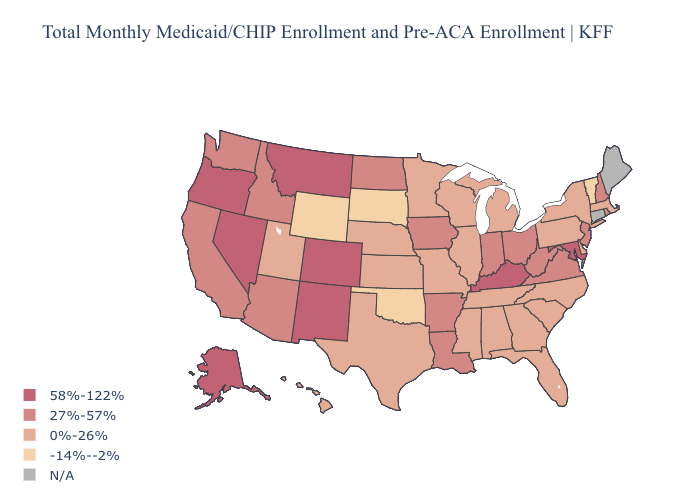Does the map have missing data?
Quick response, please. Yes. What is the value of South Dakota?
Write a very short answer. -14%--2%. Name the states that have a value in the range 58%-122%?
Short answer required. Alaska, Colorado, Kentucky, Maryland, Montana, Nevada, New Mexico, Oregon. What is the lowest value in the West?
Be succinct. -14%--2%. What is the highest value in states that border Massachusetts?
Short answer required. 27%-57%. Name the states that have a value in the range 27%-57%?
Write a very short answer. Arizona, Arkansas, California, Idaho, Indiana, Iowa, Louisiana, New Hampshire, New Jersey, North Dakota, Ohio, Rhode Island, Virginia, Washington, West Virginia. How many symbols are there in the legend?
Write a very short answer. 5. Among the states that border Arkansas , does Oklahoma have the highest value?
Short answer required. No. Does Vermont have the lowest value in the USA?
Short answer required. Yes. Name the states that have a value in the range 27%-57%?
Give a very brief answer. Arizona, Arkansas, California, Idaho, Indiana, Iowa, Louisiana, New Hampshire, New Jersey, North Dakota, Ohio, Rhode Island, Virginia, Washington, West Virginia. What is the value of Louisiana?
Be succinct. 27%-57%. Does Kentucky have the highest value in the USA?
Quick response, please. Yes. 